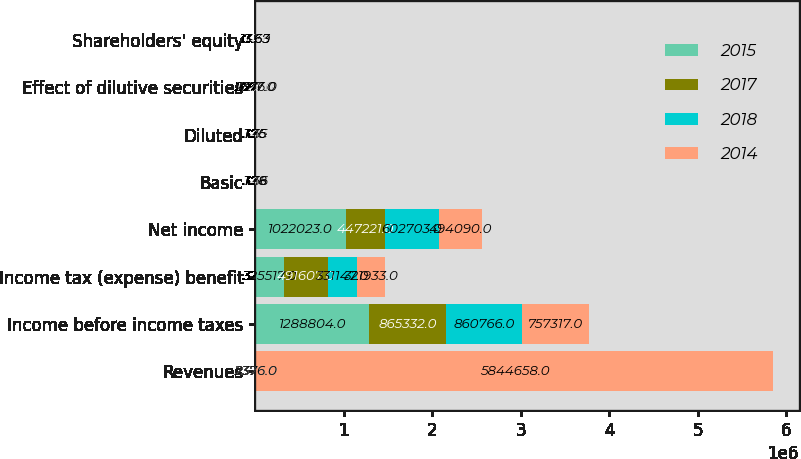<chart> <loc_0><loc_0><loc_500><loc_500><stacked_bar_chart><ecel><fcel>Revenues<fcel>Income before income taxes<fcel>Income tax (expense) benefit<fcel>Net income<fcel>Basic<fcel>Diluted<fcel>Effect of dilutive securities<fcel>Shareholders' equity<nl><fcel>2015<fcel>2376<fcel>1.2888e+06<fcel>325517<fcel>1.02202e+06<fcel>3.56<fcel>3.55<fcel>1287<fcel>17.39<nl><fcel>2017<fcel>2376<fcel>865332<fcel>491607<fcel>447221<fcel>1.45<fcel>1.44<fcel>1725<fcel>14.6<nl><fcel>2018<fcel>2376<fcel>860766<fcel>331147<fcel>602703<fcel>1.76<fcel>1.75<fcel>2376<fcel>13.63<nl><fcel>2014<fcel>5.84466e+06<fcel>757317<fcel>321933<fcel>494090<fcel>1.38<fcel>1.36<fcel>3217<fcel>13.63<nl></chart> 